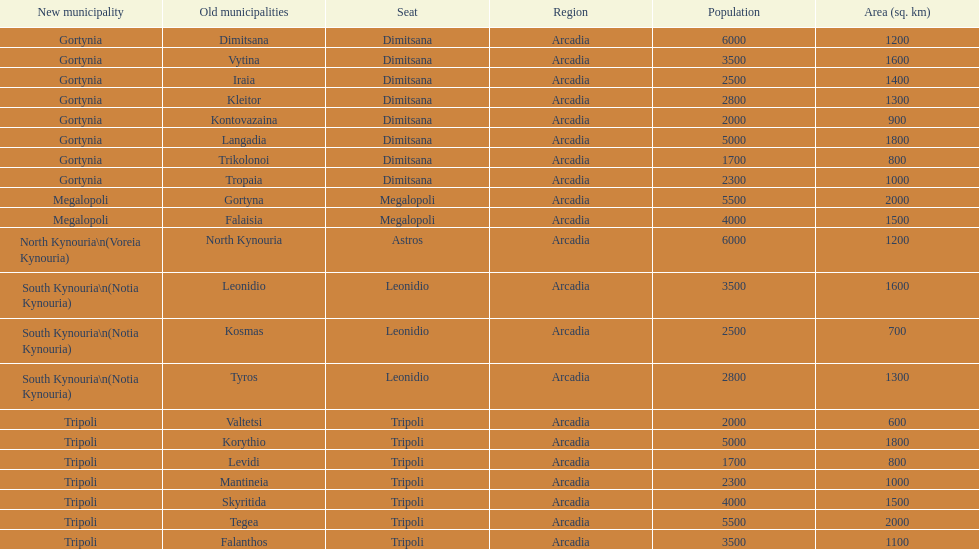How many old municipalities were in tripoli? 8. 